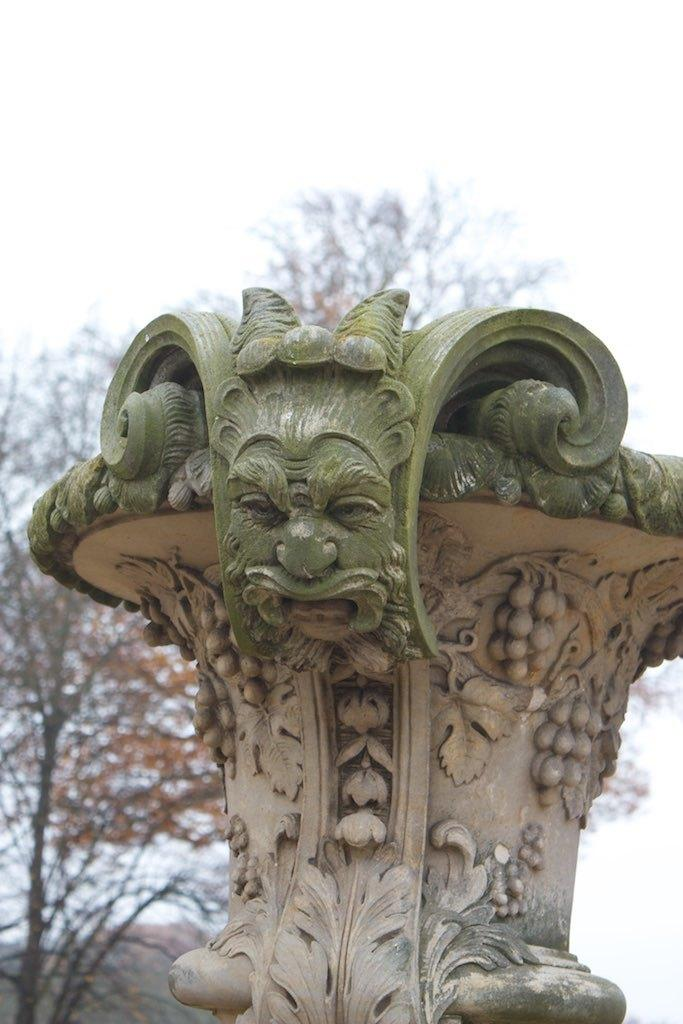What type of object is featured in the image? The image contains a carved stone. What can be seen in the background of the image? There are trees in the background of the image. What is visible at the top of the image? The sky is visible at the top of the image. What type of beetle can be seen crawling on the carved stone in the image? There is no beetle present in the image; it only features a carved stone and the surrounding environment. 